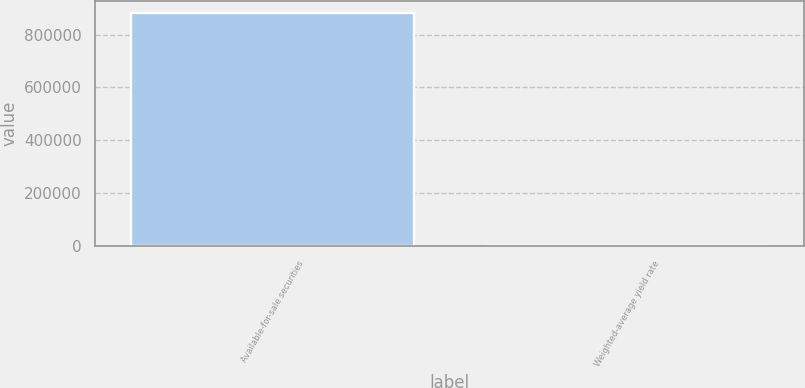Convert chart. <chart><loc_0><loc_0><loc_500><loc_500><bar_chart><fcel>Available-for-sale securities<fcel>Weighted-average yield rate<nl><fcel>883305<fcel>0.95<nl></chart> 